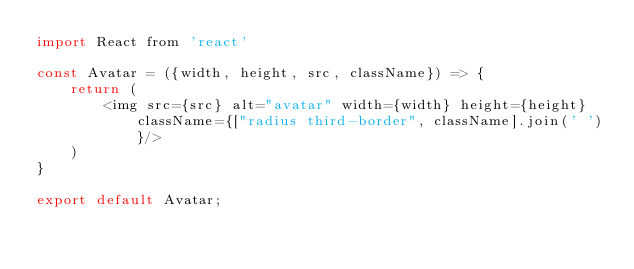<code> <loc_0><loc_0><loc_500><loc_500><_JavaScript_>import React from 'react'

const Avatar = ({width, height, src, className}) => {
    return (
        <img src={src} alt="avatar" width={width} height={height} className={["radius third-border", className].join(' ')}/>
    )
}

export default Avatar;</code> 